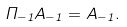Convert formula to latex. <formula><loc_0><loc_0><loc_500><loc_500>\Pi _ { - 1 } A _ { - 1 } = A _ { - 1 } .</formula> 